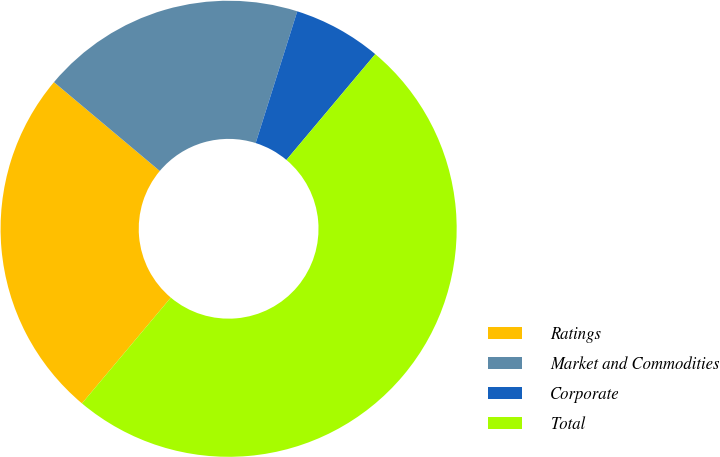Convert chart. <chart><loc_0><loc_0><loc_500><loc_500><pie_chart><fcel>Ratings<fcel>Market and Commodities<fcel>Corporate<fcel>Total<nl><fcel>25.0%<fcel>18.75%<fcel>6.25%<fcel>50.0%<nl></chart> 